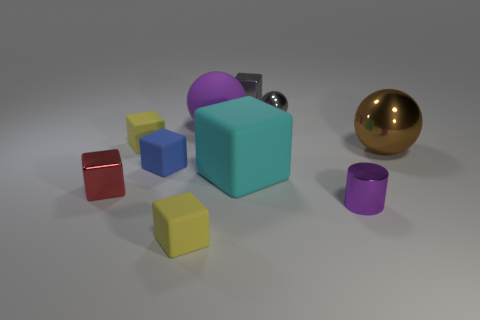Subtract all metallic blocks. How many blocks are left? 4 Subtract all cyan cubes. How many cubes are left? 5 Subtract all cyan cubes. Subtract all purple spheres. How many cubes are left? 5 Subtract all blocks. How many objects are left? 4 Add 9 brown metallic balls. How many brown metallic balls exist? 10 Subtract 0 red cylinders. How many objects are left? 10 Subtract all large red balls. Subtract all purple things. How many objects are left? 8 Add 7 purple cylinders. How many purple cylinders are left? 8 